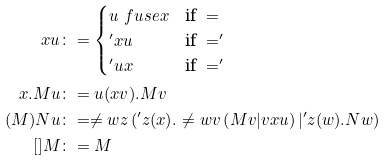Convert formula to latex. <formula><loc_0><loc_0><loc_500><loc_500>x u & \colon = \begin{cases} u \ f u s e x & \text {if } = \\ ^ { \prime } x u & \text {if } = ^ { \prime } \\ ^ { \prime } u x & \text {if } = ^ { \prime } \end{cases} \\ x . M u & \colon = u ( x v ) . M v \\ ( M ) N u & \colon = \ne w { z } \left ( ^ { \prime } z ( x ) . \ne w { v } \left ( M v | v x u \right ) | ^ { \prime } z ( w ) . N w \right ) \\ [ ] M & \colon = M</formula> 